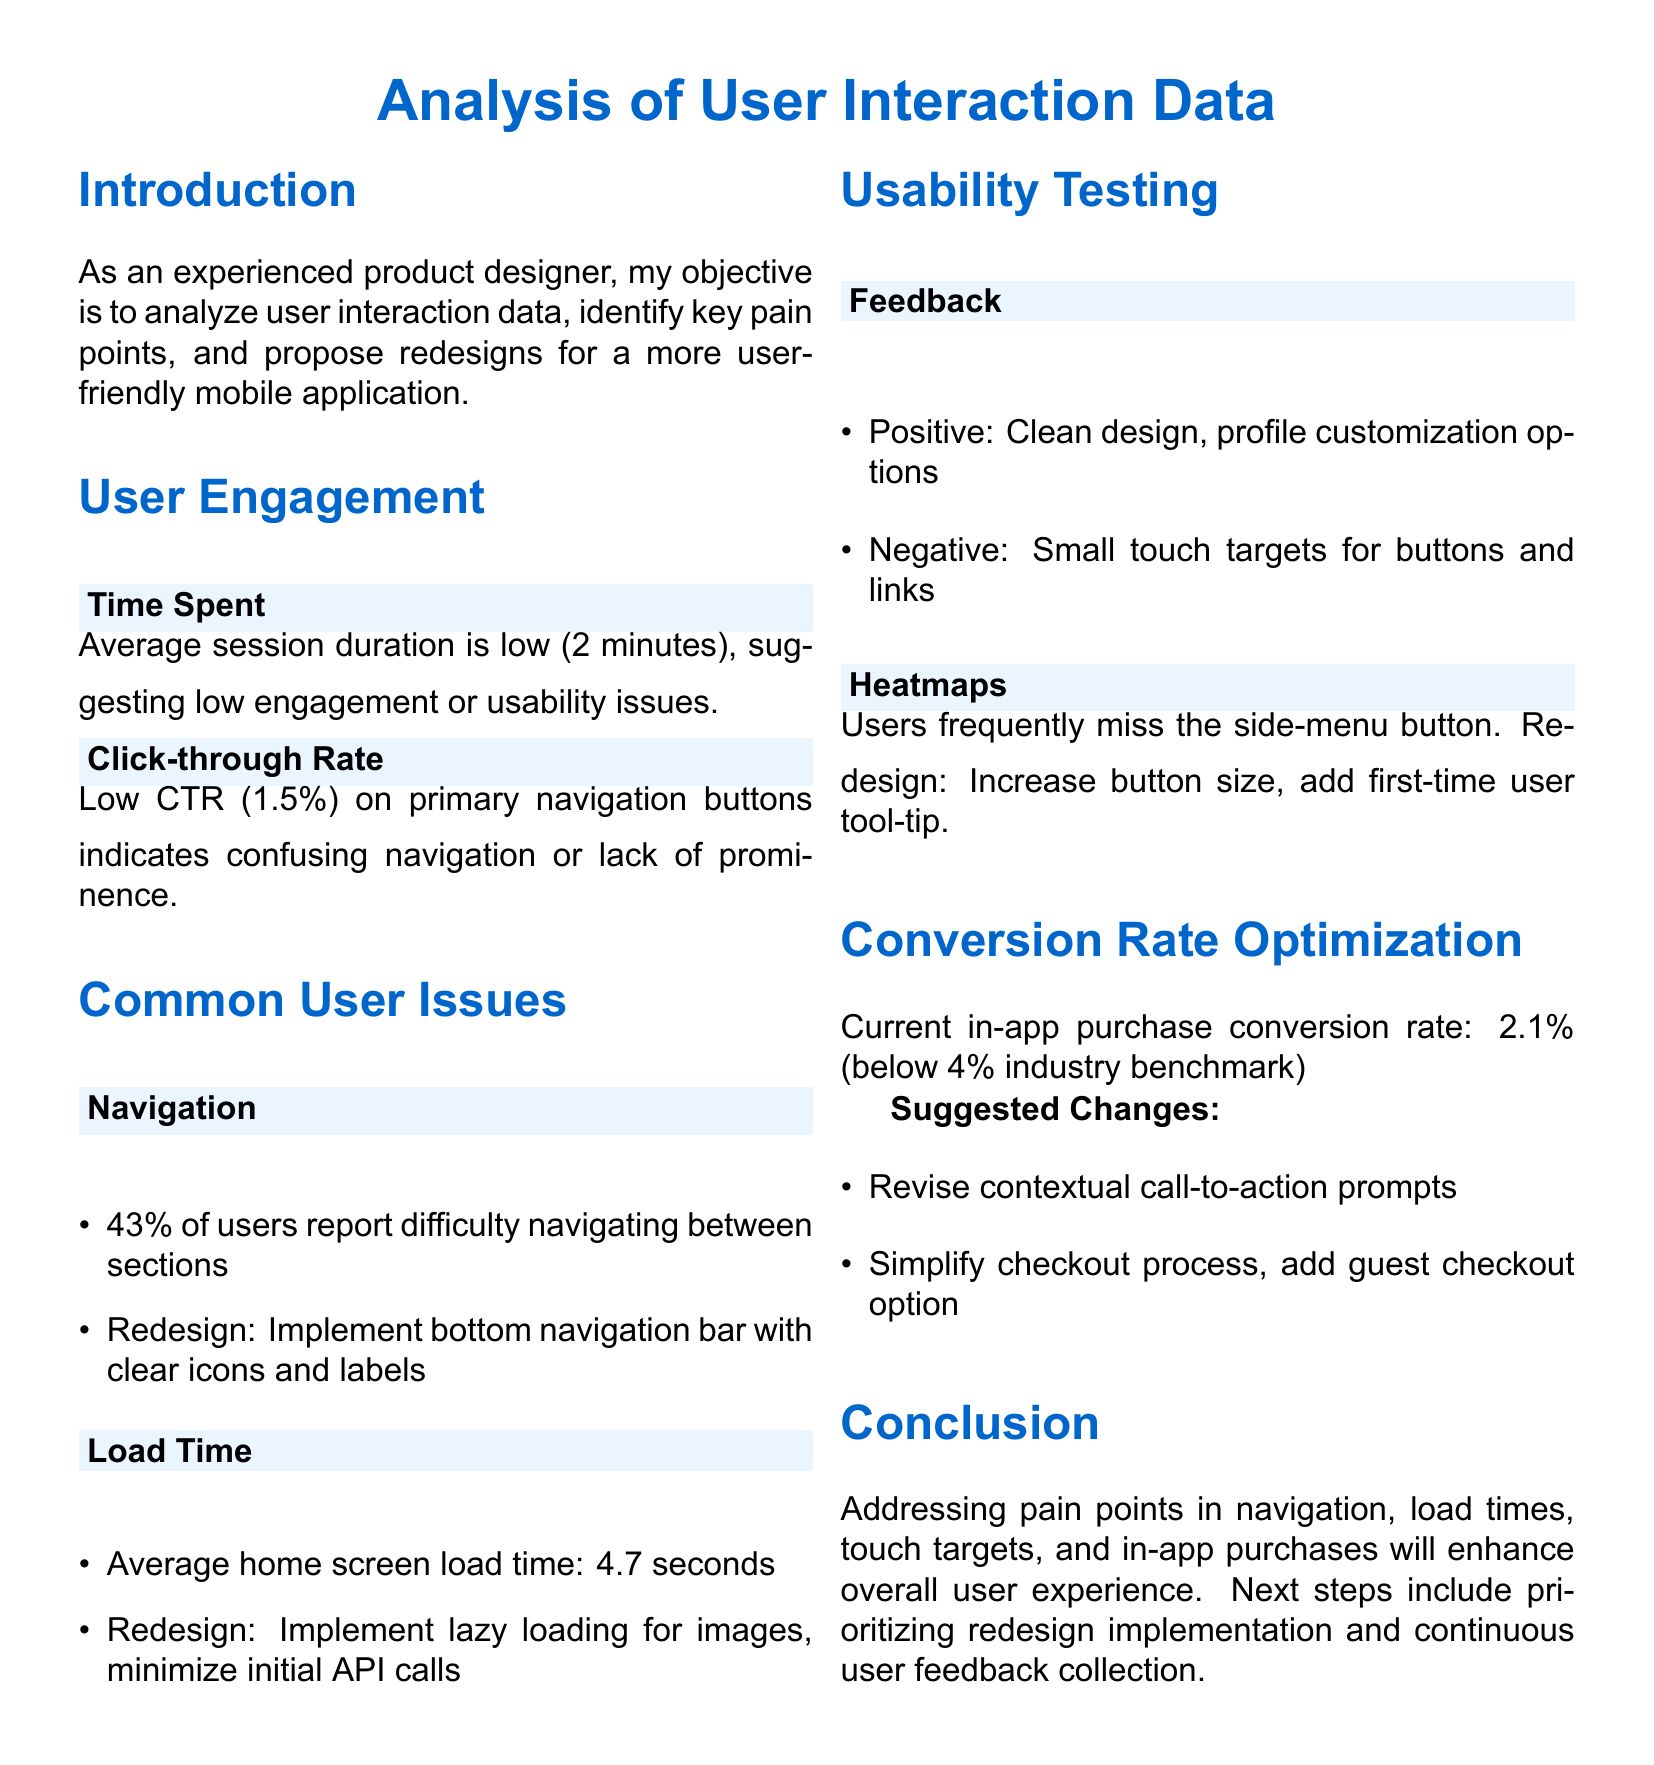What is the average session duration? The average session duration is mentioned as an indicator of user engagement.
Answer: 2 minutes What percentage of users report difficulty navigating between sections? The document specifies the percentage of users who encounter navigation issues.
Answer: 43% What is the current in-app purchase conversion rate? The conversion rate is stated in the context of conversion rate optimization.
Answer: 2.1% What redesign is suggested for improving load time? Suggested changes for load time are given in the document.
Answer: Implement lazy loading for images What positive feedback is noted from usability testing? The document lists the positive feedback received during usability testing.
Answer: Clean design What redesign is proposed for the side-menu button? The document mentions a specific redesign for the side-menu button based on user behavior.
Answer: Increase button size What is the click-through rate on primary navigation buttons? The document provides the click-through rate, signaling navigation issues.
Answer: 1.5% What is the average home screen load time? The average load time for the home screen is specified in the analysis.
Answer: 4.7 seconds What change is suggested to simplify the checkout process? The document recommends a specific change to improve the checkout experience.
Answer: Add guest checkout option 